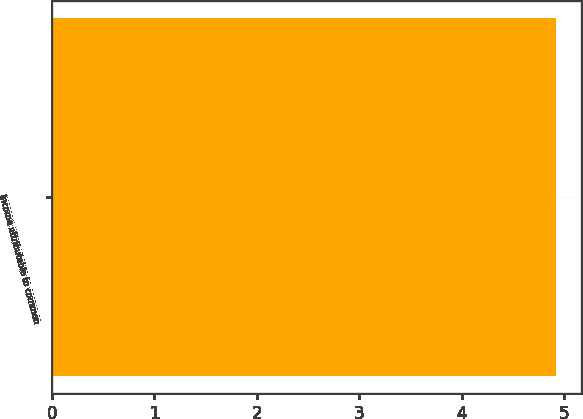Convert chart. <chart><loc_0><loc_0><loc_500><loc_500><bar_chart><fcel>Income attributable to common<nl><fcel>4.92<nl></chart> 